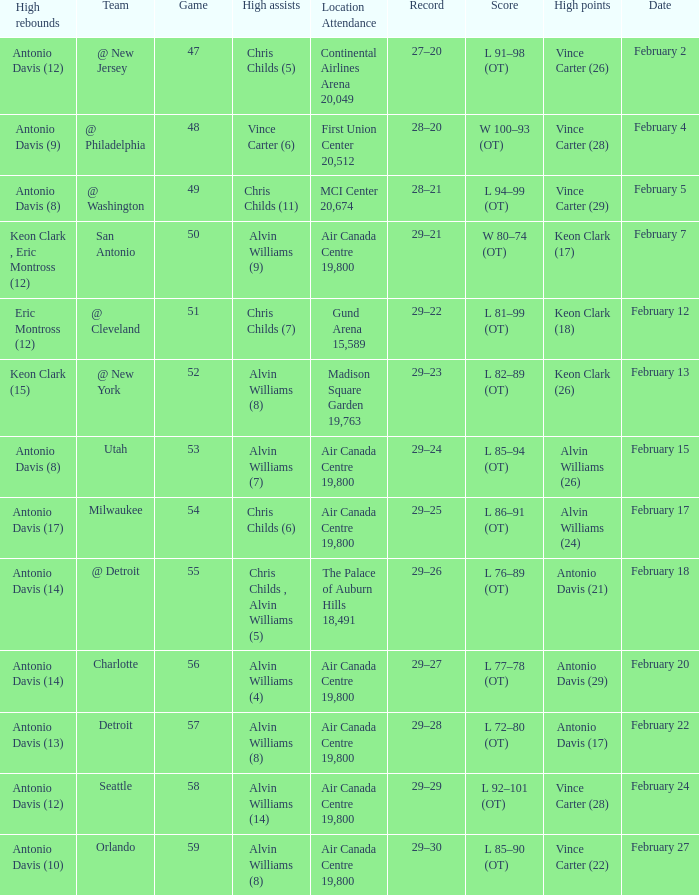What is the Team with a game of more than 56, and the score is l 85–90 (ot)? Orlando. 